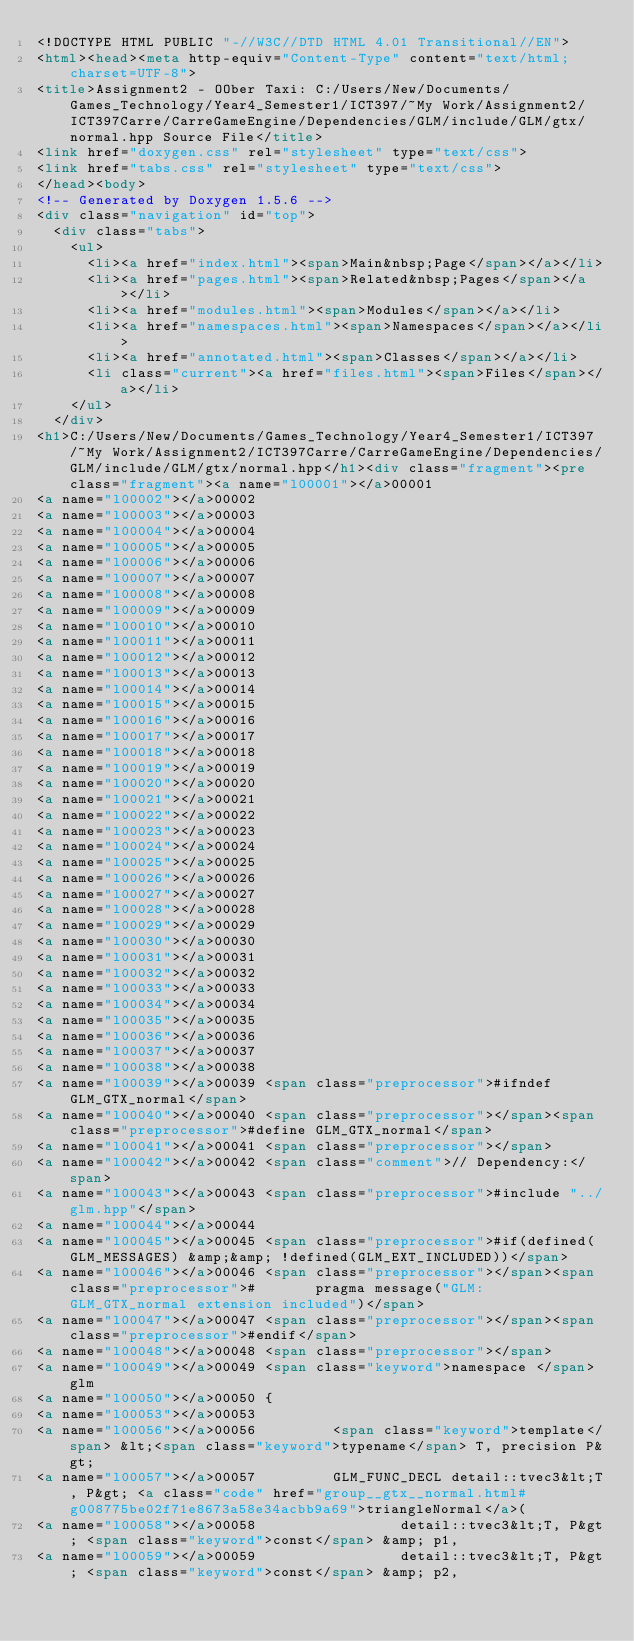Convert code to text. <code><loc_0><loc_0><loc_500><loc_500><_HTML_><!DOCTYPE HTML PUBLIC "-//W3C//DTD HTML 4.01 Transitional//EN">
<html><head><meta http-equiv="Content-Type" content="text/html;charset=UTF-8">
<title>Assignment2 - OOber Taxi: C:/Users/New/Documents/Games_Technology/Year4_Semester1/ICT397/~My Work/Assignment2/ICT397Carre/CarreGameEngine/Dependencies/GLM/include/GLM/gtx/normal.hpp Source File</title>
<link href="doxygen.css" rel="stylesheet" type="text/css">
<link href="tabs.css" rel="stylesheet" type="text/css">
</head><body>
<!-- Generated by Doxygen 1.5.6 -->
<div class="navigation" id="top">
  <div class="tabs">
    <ul>
      <li><a href="index.html"><span>Main&nbsp;Page</span></a></li>
      <li><a href="pages.html"><span>Related&nbsp;Pages</span></a></li>
      <li><a href="modules.html"><span>Modules</span></a></li>
      <li><a href="namespaces.html"><span>Namespaces</span></a></li>
      <li><a href="annotated.html"><span>Classes</span></a></li>
      <li class="current"><a href="files.html"><span>Files</span></a></li>
    </ul>
  </div>
<h1>C:/Users/New/Documents/Games_Technology/Year4_Semester1/ICT397/~My Work/Assignment2/ICT397Carre/CarreGameEngine/Dependencies/GLM/include/GLM/gtx/normal.hpp</h1><div class="fragment"><pre class="fragment"><a name="l00001"></a>00001 
<a name="l00002"></a>00002 
<a name="l00003"></a>00003 
<a name="l00004"></a>00004 
<a name="l00005"></a>00005 
<a name="l00006"></a>00006 
<a name="l00007"></a>00007 
<a name="l00008"></a>00008 
<a name="l00009"></a>00009 
<a name="l00010"></a>00010 
<a name="l00011"></a>00011 
<a name="l00012"></a>00012 
<a name="l00013"></a>00013 
<a name="l00014"></a>00014 
<a name="l00015"></a>00015 
<a name="l00016"></a>00016 
<a name="l00017"></a>00017 
<a name="l00018"></a>00018 
<a name="l00019"></a>00019 
<a name="l00020"></a>00020 
<a name="l00021"></a>00021 
<a name="l00022"></a>00022 
<a name="l00023"></a>00023 
<a name="l00024"></a>00024 
<a name="l00025"></a>00025 
<a name="l00026"></a>00026 
<a name="l00027"></a>00027 
<a name="l00028"></a>00028 
<a name="l00029"></a>00029 
<a name="l00030"></a>00030 
<a name="l00031"></a>00031 
<a name="l00032"></a>00032 
<a name="l00033"></a>00033 
<a name="l00034"></a>00034 
<a name="l00035"></a>00035 
<a name="l00036"></a>00036 
<a name="l00037"></a>00037 
<a name="l00038"></a>00038 
<a name="l00039"></a>00039 <span class="preprocessor">#ifndef GLM_GTX_normal</span>
<a name="l00040"></a>00040 <span class="preprocessor"></span><span class="preprocessor">#define GLM_GTX_normal</span>
<a name="l00041"></a>00041 <span class="preprocessor"></span>
<a name="l00042"></a>00042 <span class="comment">// Dependency:</span>
<a name="l00043"></a>00043 <span class="preprocessor">#include "../glm.hpp"</span>
<a name="l00044"></a>00044 
<a name="l00045"></a>00045 <span class="preprocessor">#if(defined(GLM_MESSAGES) &amp;&amp; !defined(GLM_EXT_INCLUDED))</span>
<a name="l00046"></a>00046 <span class="preprocessor"></span><span class="preprocessor">#       pragma message("GLM: GLM_GTX_normal extension included")</span>
<a name="l00047"></a>00047 <span class="preprocessor"></span><span class="preprocessor">#endif</span>
<a name="l00048"></a>00048 <span class="preprocessor"></span>
<a name="l00049"></a>00049 <span class="keyword">namespace </span>glm
<a name="l00050"></a>00050 {
<a name="l00053"></a>00053 
<a name="l00056"></a>00056         <span class="keyword">template</span> &lt;<span class="keyword">typename</span> T, precision P&gt; 
<a name="l00057"></a>00057         GLM_FUNC_DECL detail::tvec3&lt;T, P&gt; <a class="code" href="group__gtx__normal.html#g008775be02f71e8673a58e34acbb9a69">triangleNormal</a>(
<a name="l00058"></a>00058                 detail::tvec3&lt;T, P&gt; <span class="keyword">const</span> &amp; p1, 
<a name="l00059"></a>00059                 detail::tvec3&lt;T, P&gt; <span class="keyword">const</span> &amp; p2, </code> 